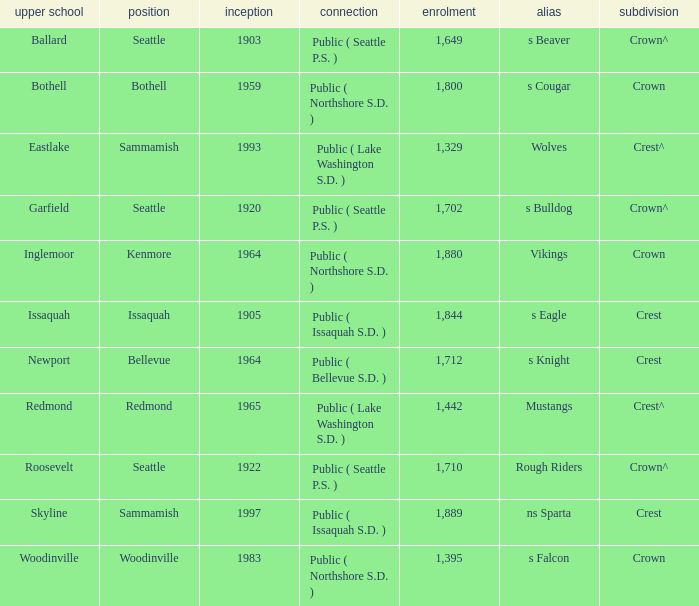What High School with a nickname of S Eagle has a Division of crest? Issaquah. 